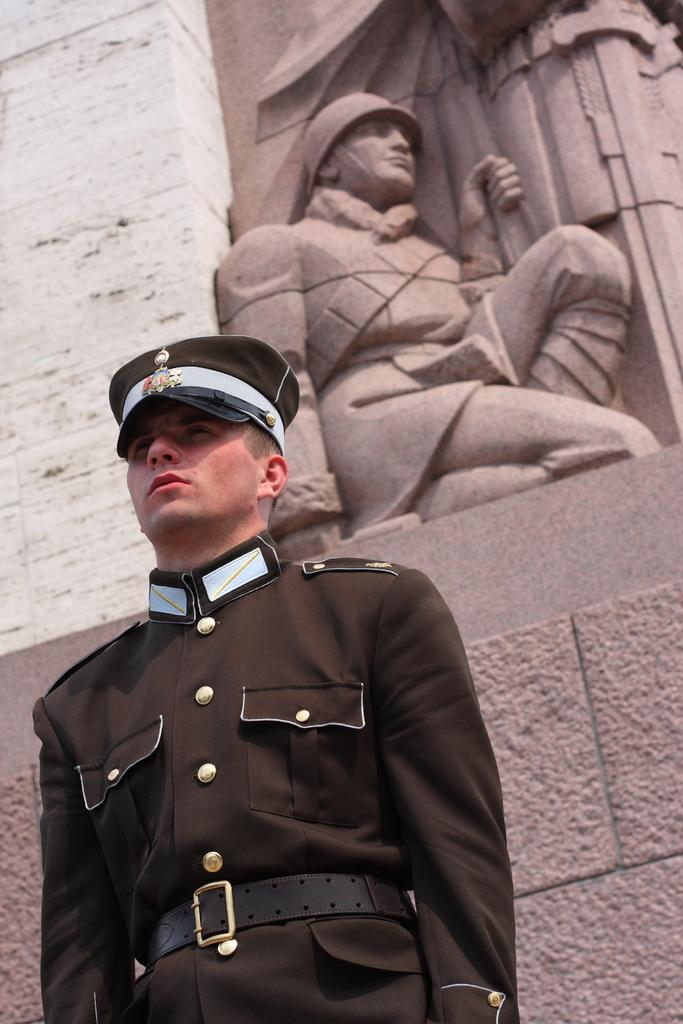Who or what is present in the image? There is a person in the image. What is the person wearing? The person is wearing a costume. What else can be seen in the image? There is a sculpture visible in the image. What type of beast can be seen interacting with the person in the image? There is no beast present in the image; it features a person wearing a costume and a sculpture. 